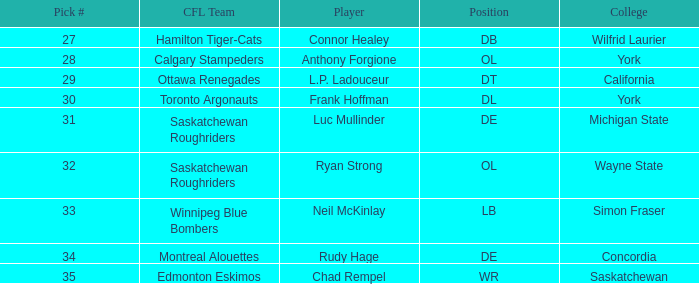What is the selection # for ryan strong? 32.0. 